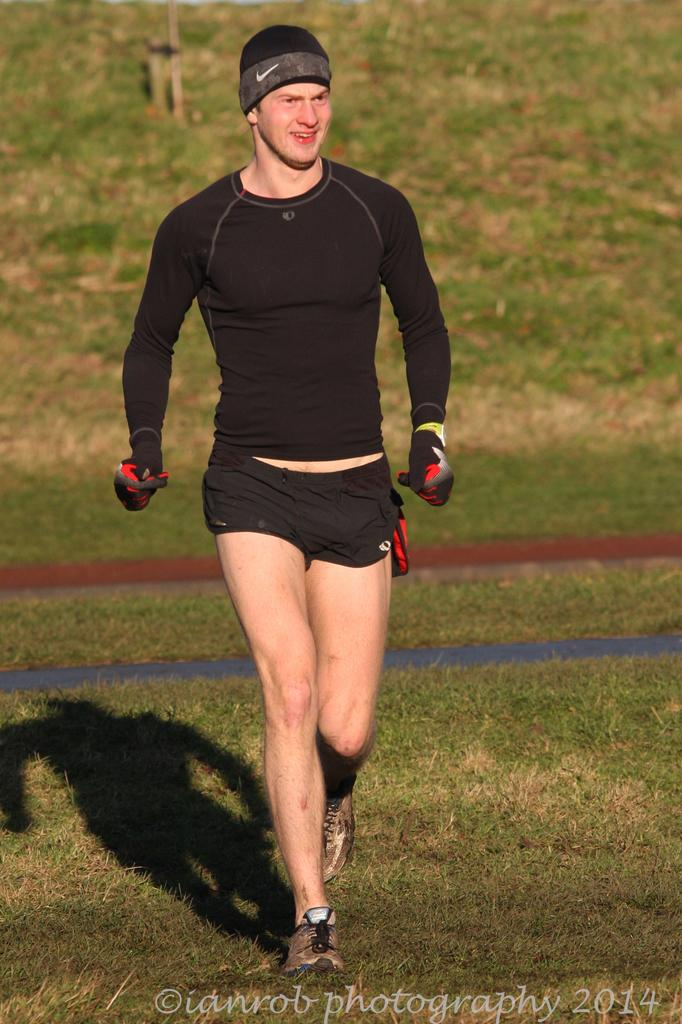What is the main subject of the image? There is a man in the image. What is the man doing in the image? The man is walking and smiling. What type of environment is visible in the image? There is grass in the image. Is there any text or marking on the image? Yes, there is a watermark at the bottom of the image. What subject is the man teaching in the image? There is no indication in the image that the man is teaching any subject. How does the man's temper affect the image? There is no information about the man's temper in the image, so it cannot be determined how it might affect the image. 